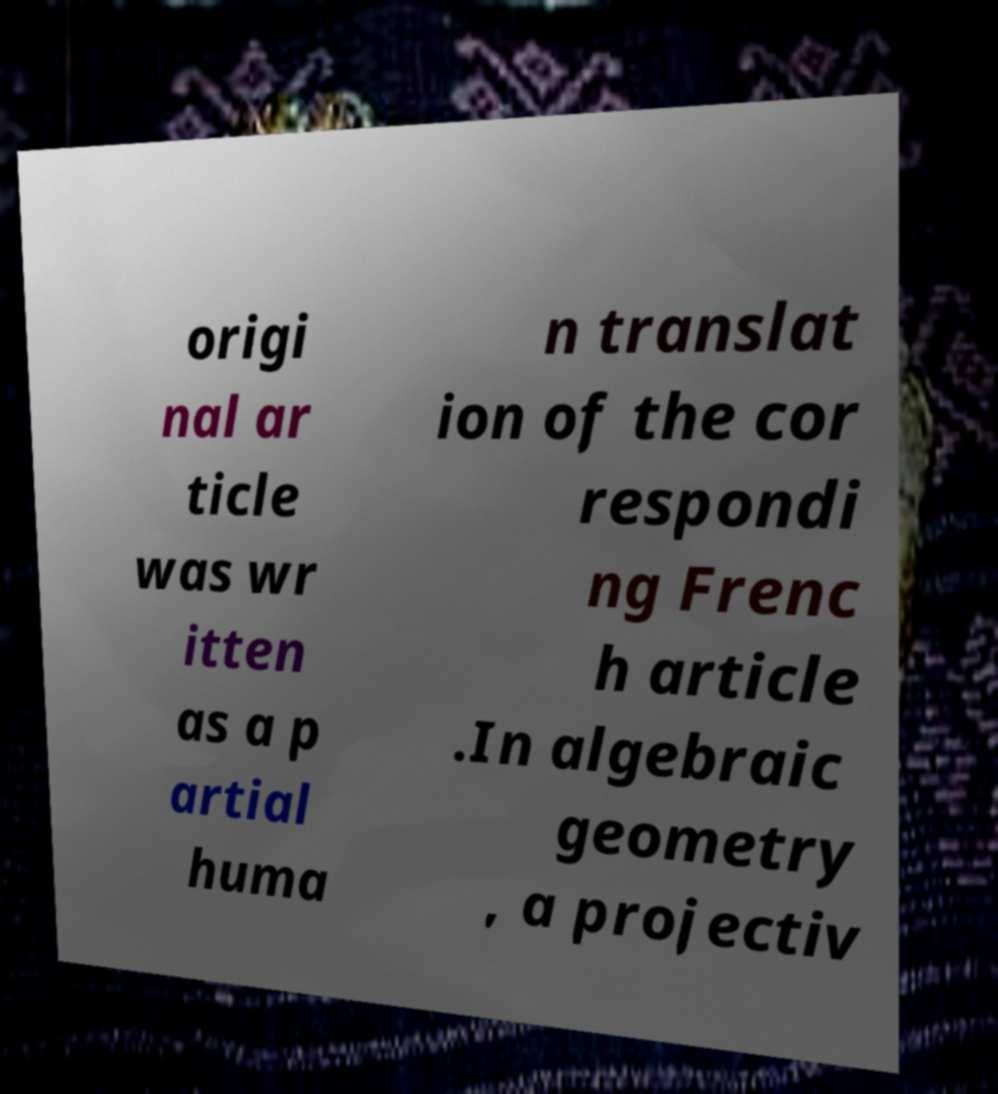I need the written content from this picture converted into text. Can you do that? origi nal ar ticle was wr itten as a p artial huma n translat ion of the cor respondi ng Frenc h article .In algebraic geometry , a projectiv 